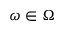<formula> <loc_0><loc_0><loc_500><loc_500>\omega \in \Omega</formula> 